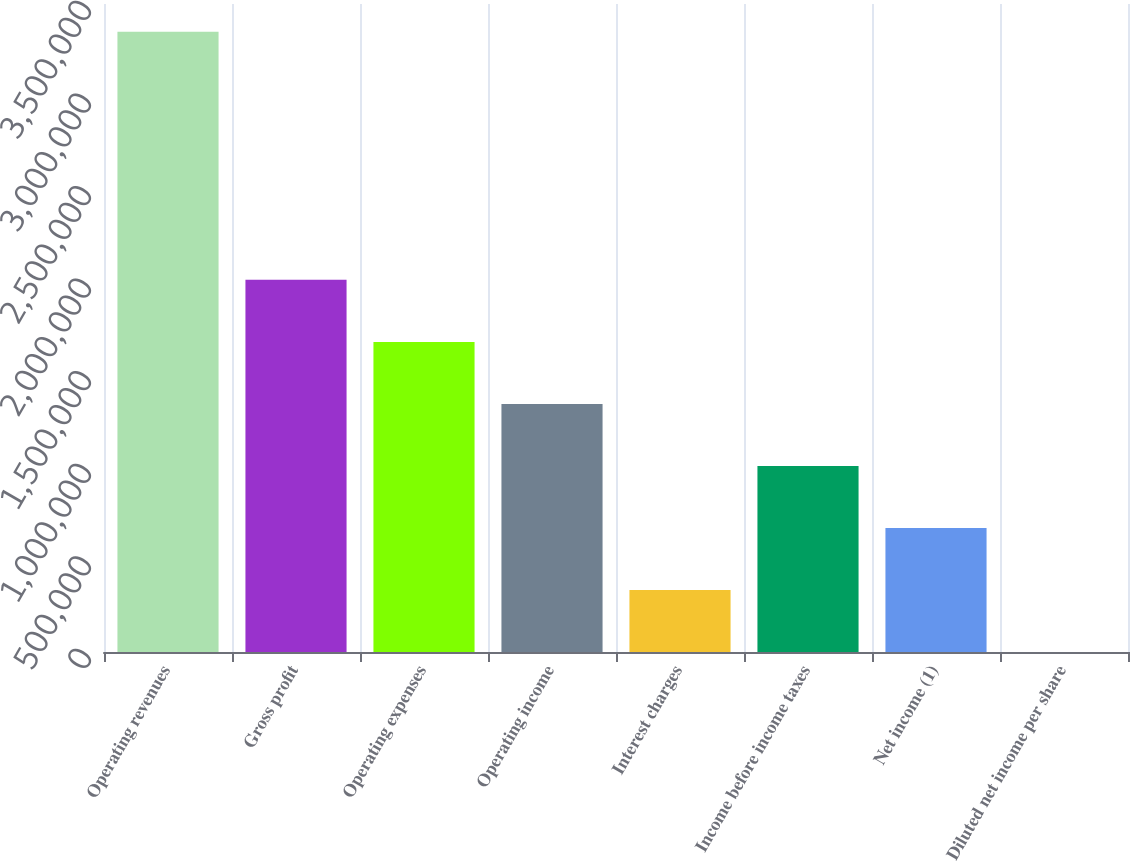Convert chart. <chart><loc_0><loc_0><loc_500><loc_500><bar_chart><fcel>Operating revenues<fcel>Gross profit<fcel>Operating expenses<fcel>Operating income<fcel>Interest charges<fcel>Income before income taxes<fcel>Net income (1)<fcel>Diluted net income per share<nl><fcel>3.34995e+06<fcel>2.00997e+06<fcel>1.67498e+06<fcel>1.33998e+06<fcel>334998<fcel>1.00499e+06<fcel>669992<fcel>3.38<nl></chart> 